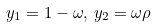<formula> <loc_0><loc_0><loc_500><loc_500>y _ { 1 } = 1 - \omega , \, y _ { 2 } = \omega \rho</formula> 